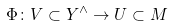<formula> <loc_0><loc_0><loc_500><loc_500>\Phi \colon V \subset Y ^ { \wedge } \to U \subset M</formula> 